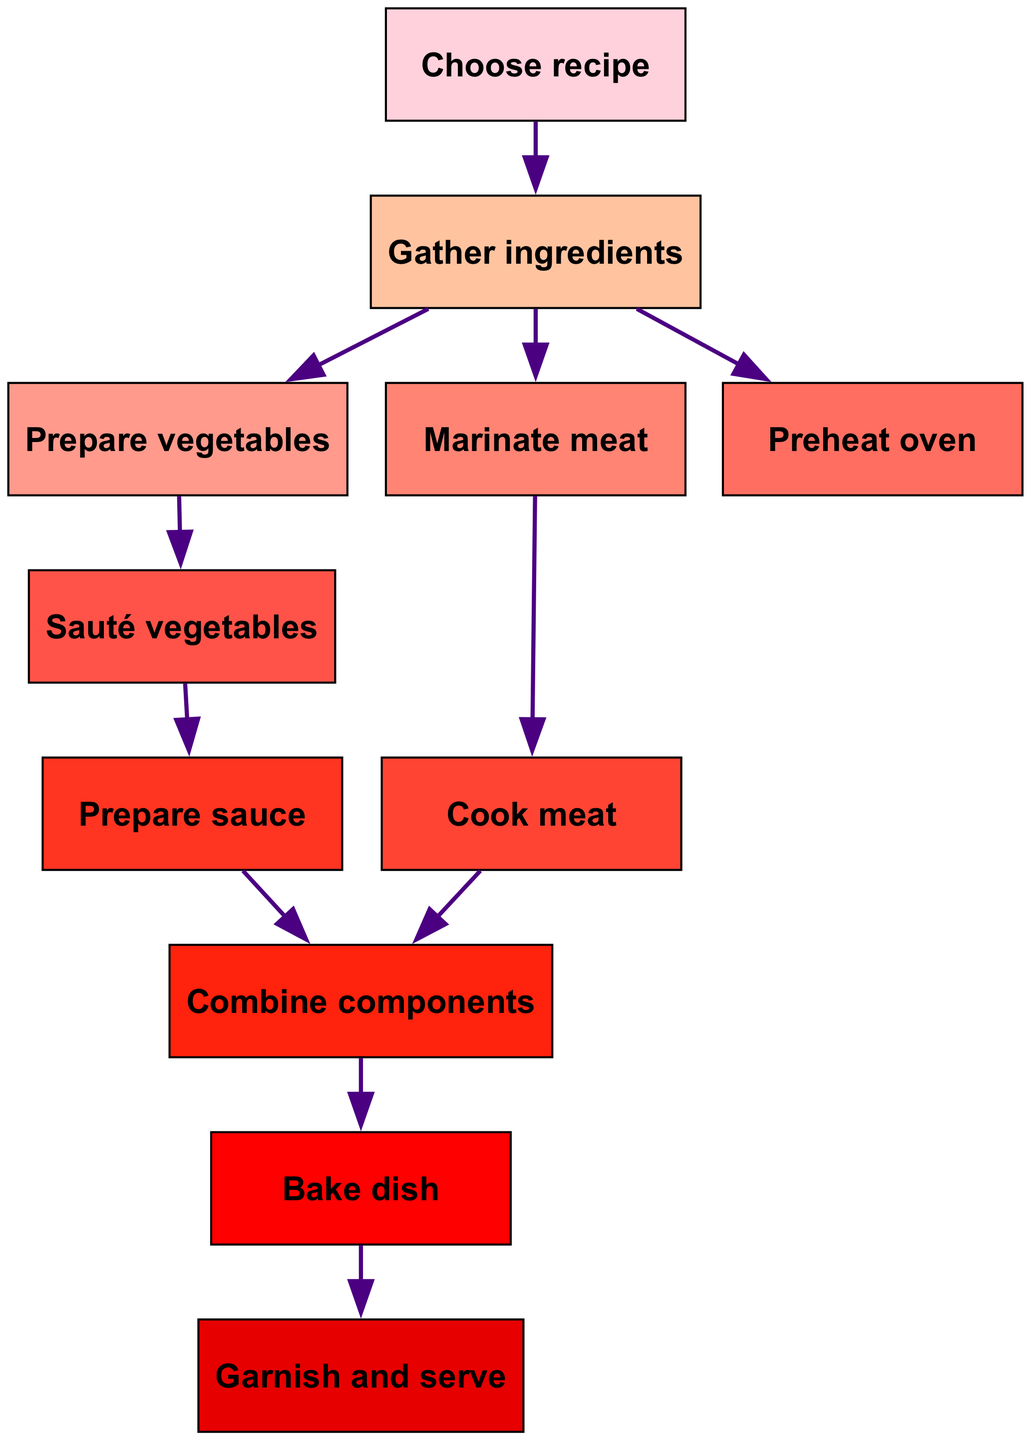What is the first step in the recipe workflow? The first step can be identified by looking at the starting node without any incoming edges, which is "Choose recipe."
Answer: Choose recipe How many nodes are in the diagram? Counting all the unique steps in the process on the diagram gives a total of 11 nodes.
Answer: 11 Which nodes precede "Bake dish"? To find the nodes that come before "Bake dish," we look for all nodes that have edges leading to "Bake dish," which are "Combine components."
Answer: Combine components What is the final step of the recipe workflow? The last node in the directed graph represents the final step, which is "Garnish and serve."
Answer: Garnish and serve How many edges are there in total? By counting all the directed connections (edges) between nodes in the diagram, we find there are 11 edges.
Answer: 11 Which step comes after "Cook meat"? The node that directly follows "Cook meat" is "Combine components," indicating the next step in the workflow after cooking the meat.
Answer: Combine components How many steps occur after "Gather ingredients"? After "Gather ingredients," there are three immediate steps: "Prepare vegetables," "Marinate meat," and "Preheat oven." Therefore, there are three steps following the initial gathering of ingredients.
Answer: 3 What two steps must occur before "Combine components"? The two steps that must occur before "Combine components" are "Cook meat" and "Prepare sauce," as both steps directly lead into the combining phase.
Answer: Cook meat and Prepare sauce What is the relationship between "Prepare vegetables" and "Sauté vegetables"? The relationship indicates that "Prepare vegetables" must precede "Sauté vegetables," as there is a directed edge from "Prepare vegetables" to "Sauté vegetables."
Answer: Precedes 